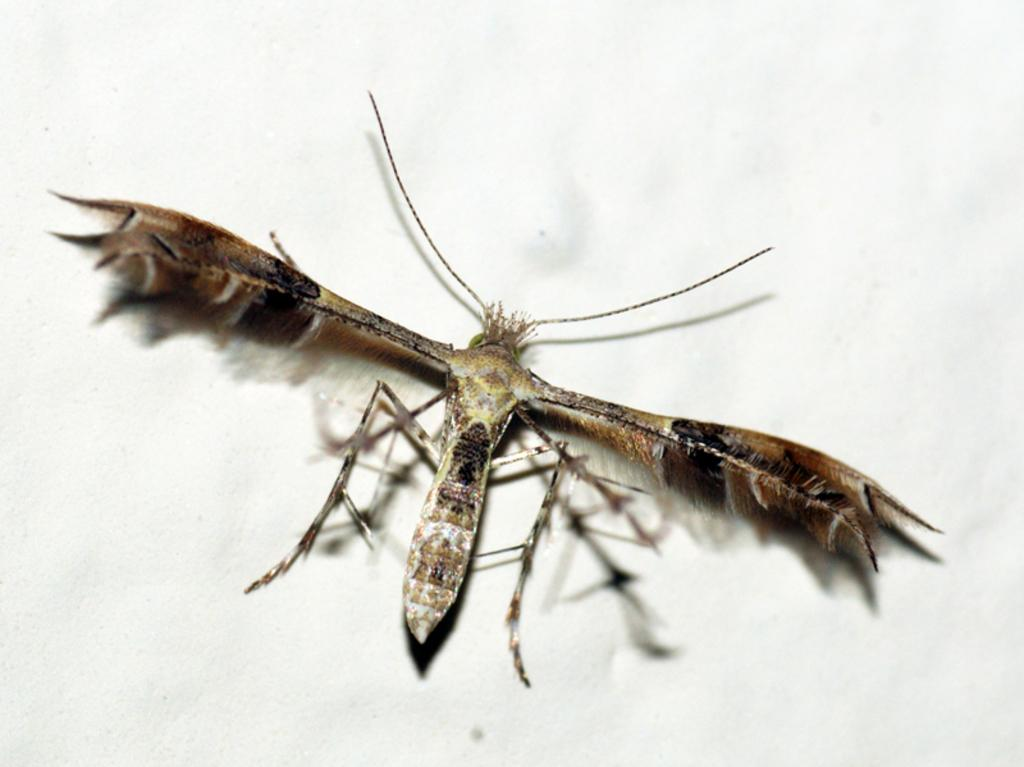What type of creature can be seen in the image? There is an insect in the image. How many tomatoes are being used to pay for the credit card bill in the image? There are no tomatoes or credit card bills present in the image; it only features an insect. 